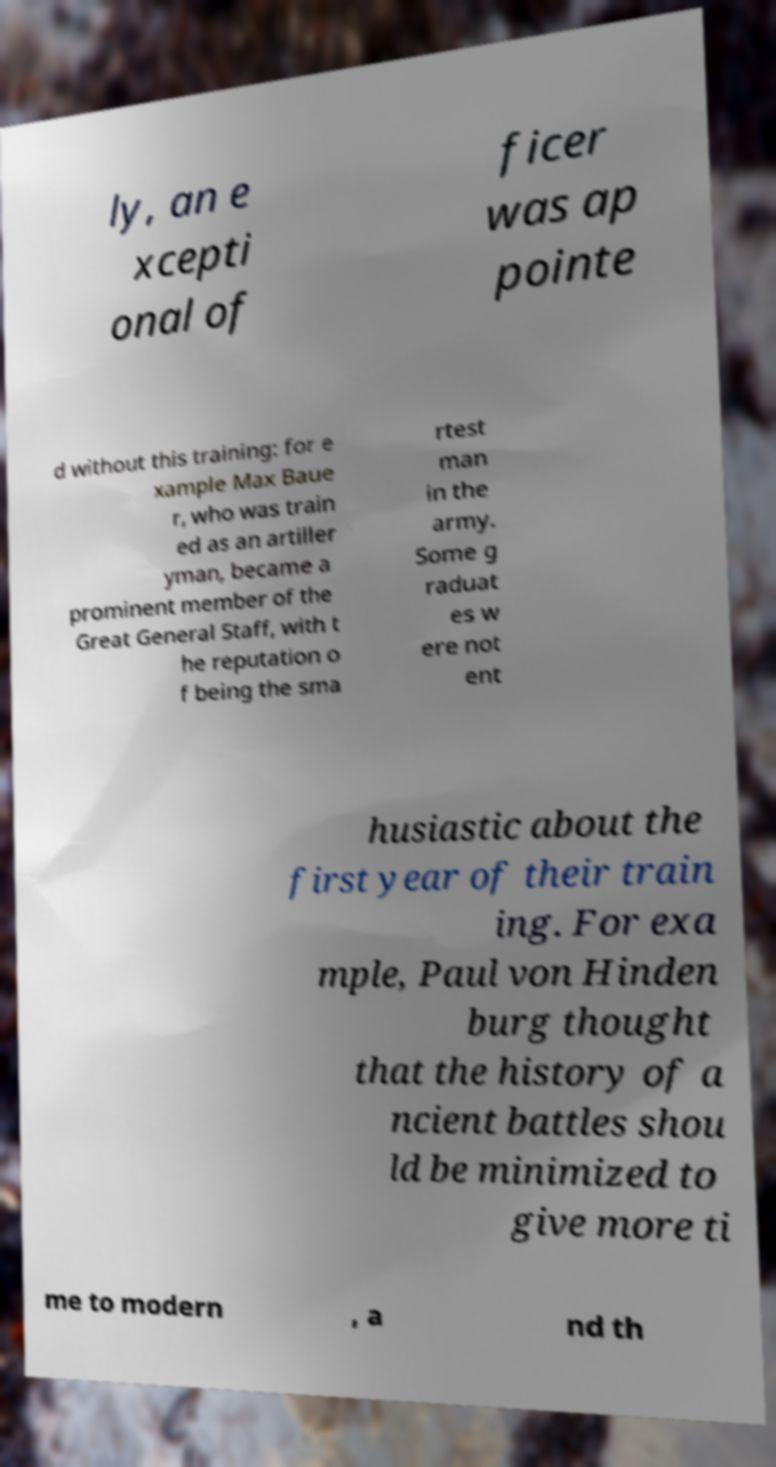What messages or text are displayed in this image? I need them in a readable, typed format. ly, an e xcepti onal of ficer was ap pointe d without this training: for e xample Max Baue r, who was train ed as an artiller yman, became a prominent member of the Great General Staff, with t he reputation o f being the sma rtest man in the army. Some g raduat es w ere not ent husiastic about the first year of their train ing. For exa mple, Paul von Hinden burg thought that the history of a ncient battles shou ld be minimized to give more ti me to modern , a nd th 